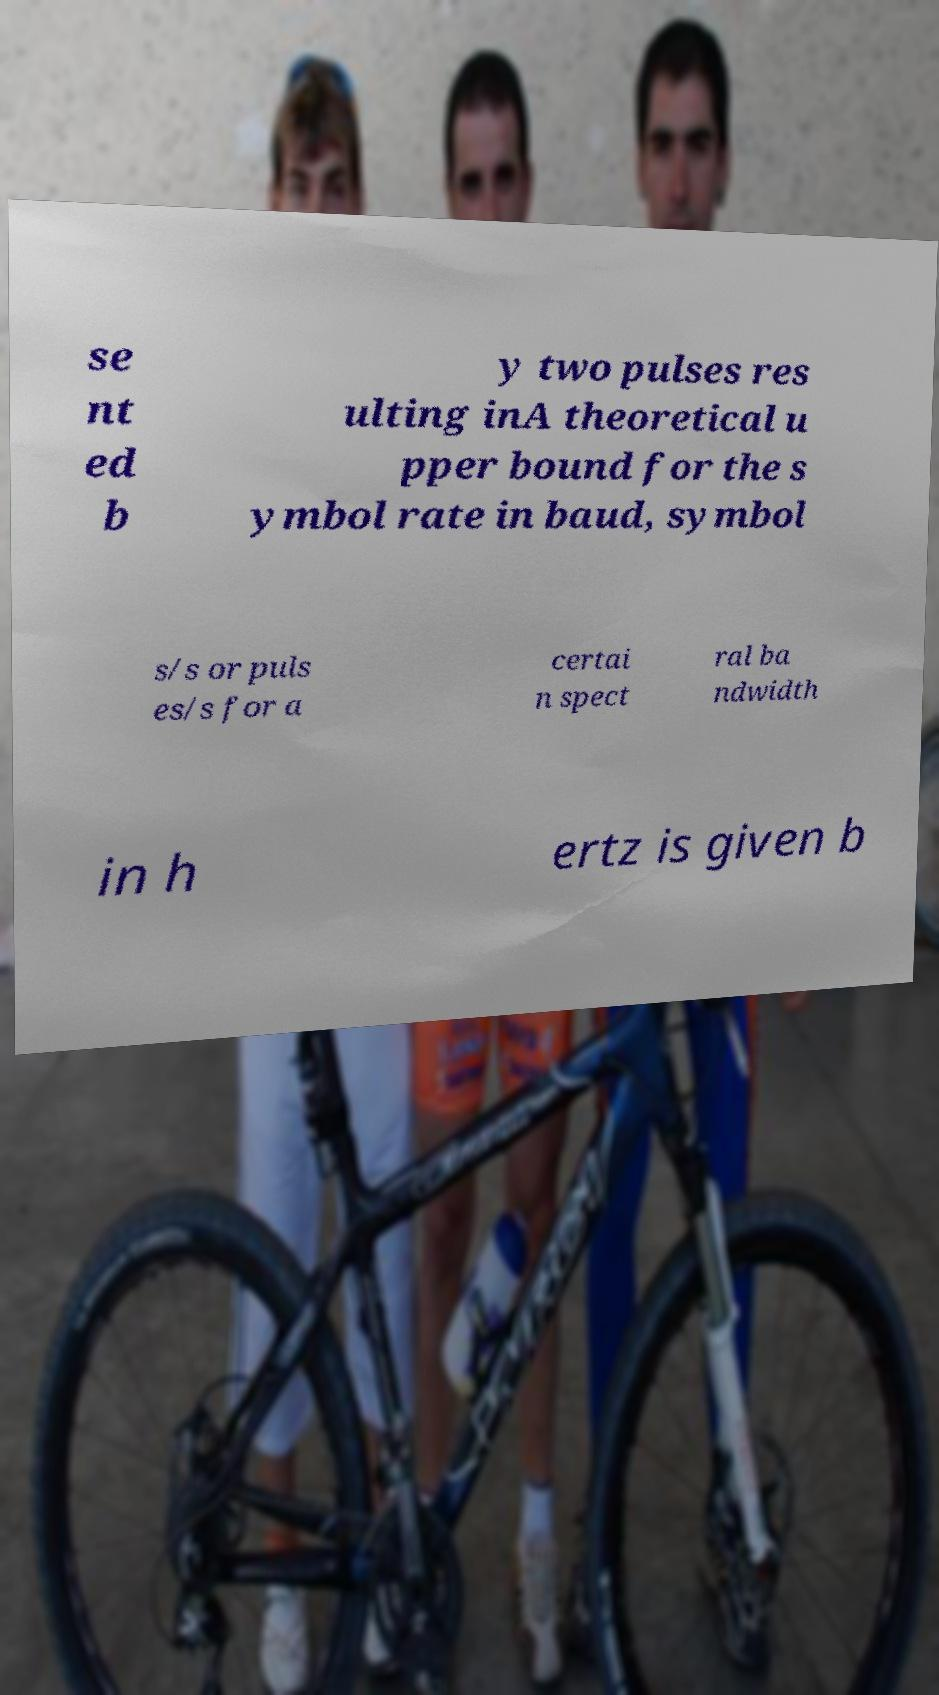For documentation purposes, I need the text within this image transcribed. Could you provide that? se nt ed b y two pulses res ulting inA theoretical u pper bound for the s ymbol rate in baud, symbol s/s or puls es/s for a certai n spect ral ba ndwidth in h ertz is given b 